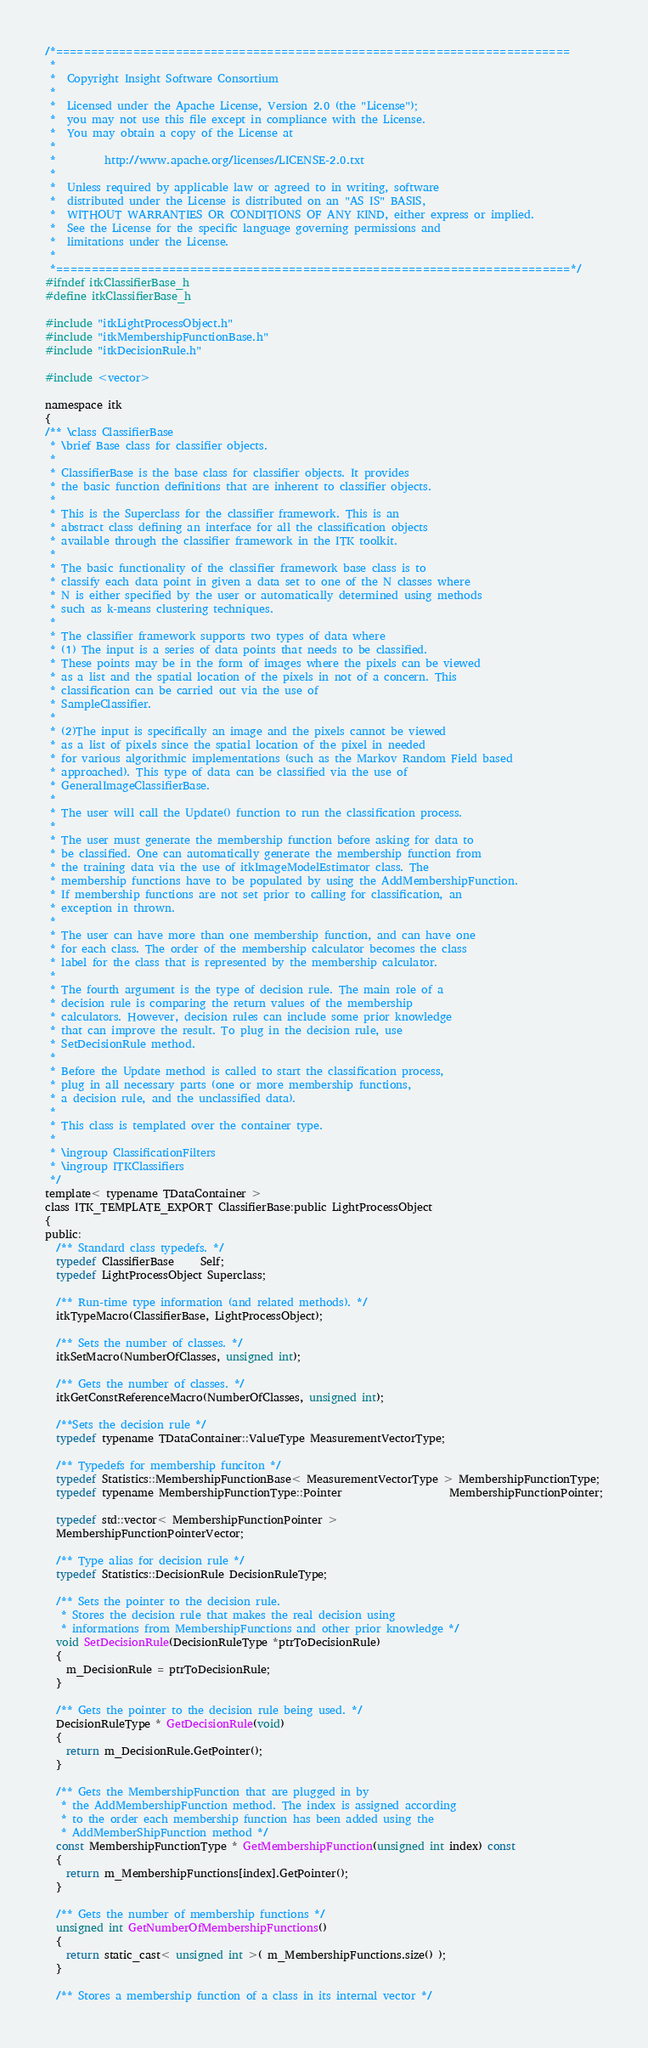<code> <loc_0><loc_0><loc_500><loc_500><_C_>/*=========================================================================
 *
 *  Copyright Insight Software Consortium
 *
 *  Licensed under the Apache License, Version 2.0 (the "License");
 *  you may not use this file except in compliance with the License.
 *  You may obtain a copy of the License at
 *
 *         http://www.apache.org/licenses/LICENSE-2.0.txt
 *
 *  Unless required by applicable law or agreed to in writing, software
 *  distributed under the License is distributed on an "AS IS" BASIS,
 *  WITHOUT WARRANTIES OR CONDITIONS OF ANY KIND, either express or implied.
 *  See the License for the specific language governing permissions and
 *  limitations under the License.
 *
 *=========================================================================*/
#ifndef itkClassifierBase_h
#define itkClassifierBase_h

#include "itkLightProcessObject.h"
#include "itkMembershipFunctionBase.h"
#include "itkDecisionRule.h"

#include <vector>

namespace itk
{
/** \class ClassifierBase
 * \brief Base class for classifier objects.
 *
 * ClassifierBase is the base class for classifier objects. It provides
 * the basic function definitions that are inherent to classifier objects.
 *
 * This is the Superclass for the classifier framework. This is an
 * abstract class defining an interface for all the classification objects
 * available through the classifier framework in the ITK toolkit.
 *
 * The basic functionality of the classifier framework base class is to
 * classify each data point in given a data set to one of the N classes where
 * N is either specified by the user or automatically determined using methods
 * such as k-means clustering techniques.
 *
 * The classifier framework supports two types of data where
 * (1) The input is a series of data points that needs to be classified.
 * These points may be in the form of images where the pixels can be viewed
 * as a list and the spatial location of the pixels in not of a concern. This
 * classification can be carried out via the use of
 * SampleClassifier.
 *
 * (2)The input is specifically an image and the pixels cannot be viewed
 * as a list of pixels since the spatial location of the pixel in needed
 * for various algorithmic implementations (such as the Markov Random Field based
 * approached). This type of data can be classified via the use of
 * GeneralImageClassifierBase.
 *
 * The user will call the Update() function to run the classification process.
 *
 * The user must generate the membership function before asking for data to
 * be classified. One can automatically generate the membership function from
 * the training data via the use of itkImageModelEstimator class. The
 * membership functions have to be populated by using the AddMembershipFunction.
 * If membership functions are not set prior to calling for classification, an
 * exception in thrown.
 *
 * The user can have more than one membership function, and can have one
 * for each class. The order of the membership calculator becomes the class
 * label for the class that is represented by the membership calculator.
 *
 * The fourth argument is the type of decision rule. The main role of a
 * decision rule is comparing the return values of the membership
 * calculators. However, decision rules can include some prior knowledge
 * that can improve the result. To plug in the decision rule, use
 * SetDecisionRule method.
 *
 * Before the Update method is called to start the classification process,
 * plug in all necessary parts (one or more membership functions,
 * a decision rule, and the unclassified data).
 *
 * This class is templated over the container type.
 *
 * \ingroup ClassificationFilters
 * \ingroup ITKClassifiers
 */
template< typename TDataContainer >
class ITK_TEMPLATE_EXPORT ClassifierBase:public LightProcessObject
{
public:
  /** Standard class typedefs. */
  typedef ClassifierBase     Self;
  typedef LightProcessObject Superclass;

  /** Run-time type information (and related methods). */
  itkTypeMacro(ClassifierBase, LightProcessObject);

  /** Sets the number of classes. */
  itkSetMacro(NumberOfClasses, unsigned int);

  /** Gets the number of classes. */
  itkGetConstReferenceMacro(NumberOfClasses, unsigned int);

  /**Sets the decision rule */
  typedef typename TDataContainer::ValueType MeasurementVectorType;

  /** Typedefs for membership funciton */
  typedef Statistics::MembershipFunctionBase< MeasurementVectorType > MembershipFunctionType;
  typedef typename MembershipFunctionType::Pointer                    MembershipFunctionPointer;

  typedef std::vector< MembershipFunctionPointer >
  MembershipFunctionPointerVector;

  /** Type alias for decision rule */
  typedef Statistics::DecisionRule DecisionRuleType;

  /** Sets the pointer to the decision rule.
   * Stores the decision rule that makes the real decision using
   * informations from MembershipFunctions and other prior knowledge */
  void SetDecisionRule(DecisionRuleType *ptrToDecisionRule)
  {
    m_DecisionRule = ptrToDecisionRule;
  }

  /** Gets the pointer to the decision rule being used. */
  DecisionRuleType * GetDecisionRule(void)
  {
    return m_DecisionRule.GetPointer();
  }

  /** Gets the MembershipFunction that are plugged in by
   * the AddMembershipFunction method. The index is assigned according
   * to the order each membership function has been added using the
   * AddMemberShipFunction method */
  const MembershipFunctionType * GetMembershipFunction(unsigned int index) const
  {
    return m_MembershipFunctions[index].GetPointer();
  }

  /** Gets the number of membership functions */
  unsigned int GetNumberOfMembershipFunctions()
  {
    return static_cast< unsigned int >( m_MembershipFunctions.size() );
  }

  /** Stores a membership function of a class in its internal vector */</code> 